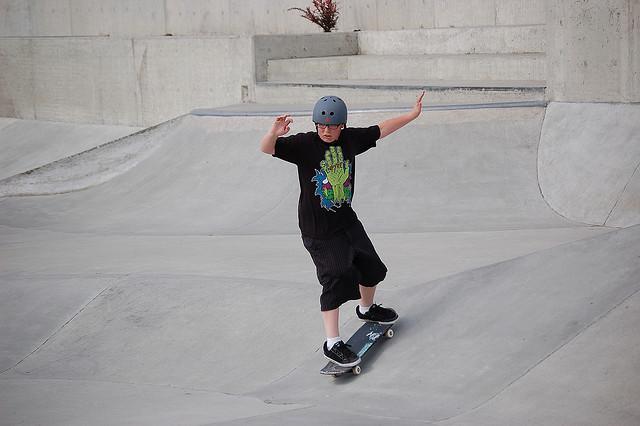What is this person doing?
Write a very short answer. Skateboarding. Is he wearing any safety gear?
Be succinct. Yes. How many steps are there?
Answer briefly. 3. 